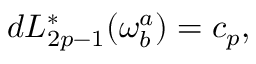Convert formula to latex. <formula><loc_0><loc_0><loc_500><loc_500>d L _ { 2 p - 1 } ^ { * } ( \omega _ { b } ^ { a } ) = c _ { p } ,</formula> 